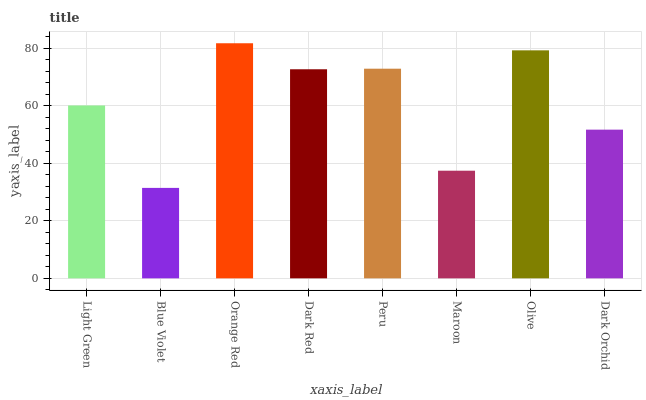Is Blue Violet the minimum?
Answer yes or no. Yes. Is Orange Red the maximum?
Answer yes or no. Yes. Is Orange Red the minimum?
Answer yes or no. No. Is Blue Violet the maximum?
Answer yes or no. No. Is Orange Red greater than Blue Violet?
Answer yes or no. Yes. Is Blue Violet less than Orange Red?
Answer yes or no. Yes. Is Blue Violet greater than Orange Red?
Answer yes or no. No. Is Orange Red less than Blue Violet?
Answer yes or no. No. Is Dark Red the high median?
Answer yes or no. Yes. Is Light Green the low median?
Answer yes or no. Yes. Is Olive the high median?
Answer yes or no. No. Is Dark Red the low median?
Answer yes or no. No. 